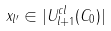<formula> <loc_0><loc_0><loc_500><loc_500>x _ { l ^ { \prime } } \in | U ^ { c l } _ { l + 1 } ( C _ { 0 } ) |</formula> 